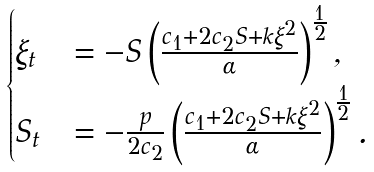<formula> <loc_0><loc_0><loc_500><loc_500>\begin{cases} \xi _ { t } & = - S \left ( \frac { c _ { 1 } + 2 c _ { 2 } S + k \xi ^ { 2 } } { \alpha } \right ) ^ { \frac { 1 } { 2 } } , \\ S _ { t } & = - \frac { p } { 2 c _ { 2 } } \left ( \frac { c _ { 1 } + 2 c _ { 2 } S + k \xi ^ { 2 } } { \alpha } \right ) ^ { \frac { 1 } { 2 } } . \end{cases}</formula> 